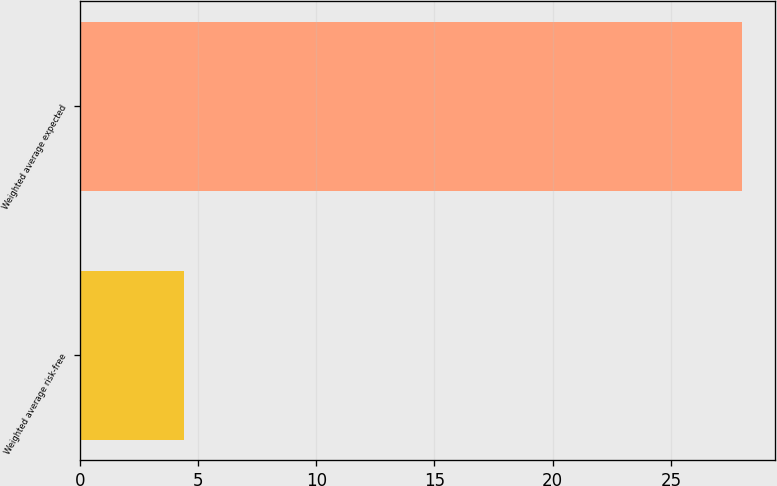<chart> <loc_0><loc_0><loc_500><loc_500><bar_chart><fcel>Weighted average risk-free<fcel>Weighted average expected<nl><fcel>4.4<fcel>28<nl></chart> 